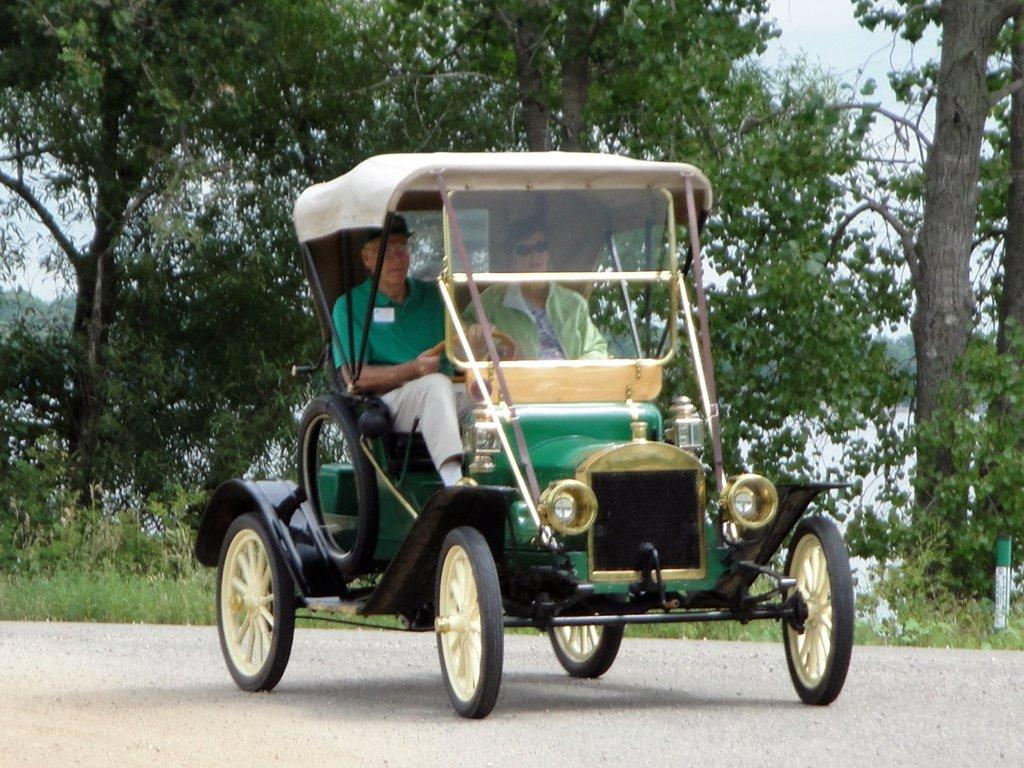What is on the road in the image? There is a vehicle on the road in the image. Who is inside the vehicle? Two men are sitting inside the vehicle. What can be seen in the background of the image? There are trees visible in the background. Where is the library located in the image? There is no library present in the image. What shape does the vehicle form as it moves along the road? The vehicle's shape cannot be determined from the image, as it is a static representation. 